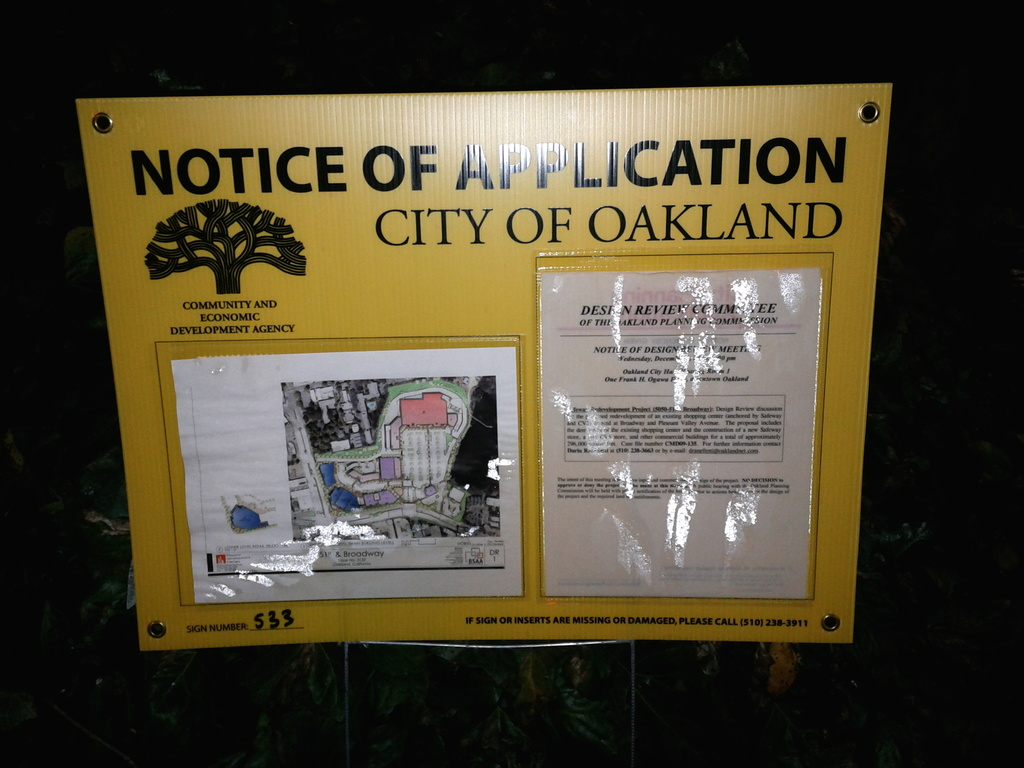What is this photo about? The photo displays a yellow 'Notice of Application' sign presented by the City of Oakland's Community and Economic Development Agency. Located on what appears to be a fence, and photographed at night, this sign announces a forthcoming public hearing concerning a proposed development project. This hearing is set to take place on Wednesday, October 3, 2012, at City Hall. The sign offers a map that outlines the affected area, suggesting the scale of the proposed changes. The clarity of the map and additional details helps citizens understand and potentially engage in the developmental proceedings that could reshape part of their community. 